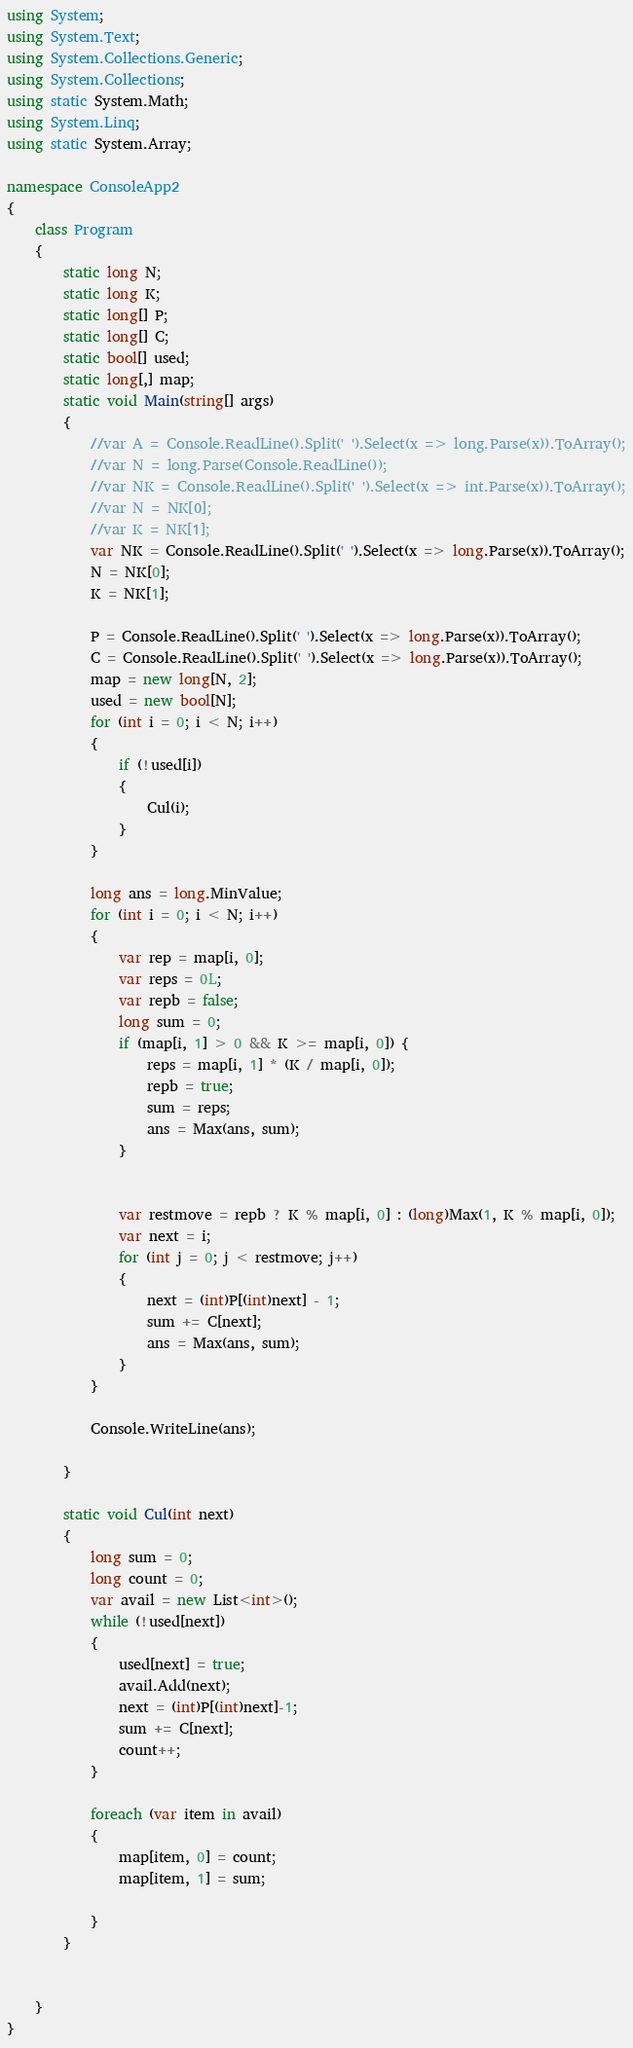Convert code to text. <code><loc_0><loc_0><loc_500><loc_500><_C#_>using System;
using System.Text;
using System.Collections.Generic;
using System.Collections;
using static System.Math;
using System.Linq;
using static System.Array;

namespace ConsoleApp2
{
    class Program
    {
        static long N;
        static long K;
        static long[] P;
        static long[] C;
        static bool[] used;
        static long[,] map;
        static void Main(string[] args)
        {
            //var A = Console.ReadLine().Split(' ').Select(x => long.Parse(x)).ToArray();
            //var N = long.Parse(Console.ReadLine());
            //var NK = Console.ReadLine().Split(' ').Select(x => int.Parse(x)).ToArray();
            //var N = NK[0];
            //var K = NK[1];
            var NK = Console.ReadLine().Split(' ').Select(x => long.Parse(x)).ToArray();
            N = NK[0];
            K = NK[1];

            P = Console.ReadLine().Split(' ').Select(x => long.Parse(x)).ToArray();
            C = Console.ReadLine().Split(' ').Select(x => long.Parse(x)).ToArray();
            map = new long[N, 2];
            used = new bool[N];
            for (int i = 0; i < N; i++)
            {
                if (!used[i])
                {
                    Cul(i);
                }
            }

            long ans = long.MinValue;
            for (int i = 0; i < N; i++)
            {
                var rep = map[i, 0];
                var reps = 0L;
                var repb = false;
                long sum = 0;
                if (map[i, 1] > 0 && K >= map[i, 0]) {
                    reps = map[i, 1] * (K / map[i, 0]);
                    repb = true;
                    sum = reps;
                    ans = Max(ans, sum);
                }
                

                var restmove = repb ? K % map[i, 0] : (long)Max(1, K % map[i, 0]);
                var next = i;
                for (int j = 0; j < restmove; j++)
                {
                    next = (int)P[(int)next] - 1;
                    sum += C[next];
                    ans = Max(ans, sum);
                }
            }

            Console.WriteLine(ans);

        }

        static void Cul(int next)
        {
            long sum = 0;
            long count = 0;
            var avail = new List<int>();
            while (!used[next])
            {
                used[next] = true;
                avail.Add(next);
                next = (int)P[(int)next]-1;
                sum += C[next];
                count++;
            }

            foreach (var item in avail)
            {
                map[item, 0] = count;
                map[item, 1] = sum;

            }
        }


    }
}
</code> 